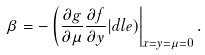<formula> <loc_0><loc_0><loc_500><loc_500>\beta = - \left ( \frac { \partial g } { \partial \mu } \frac { \partial f } { \partial y } | d l e ) \right | _ { x = y = \mu = 0 } .</formula> 